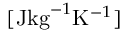<formula> <loc_0><loc_0><loc_500><loc_500>[ J k g ^ { - 1 } K ^ { - 1 } ]</formula> 